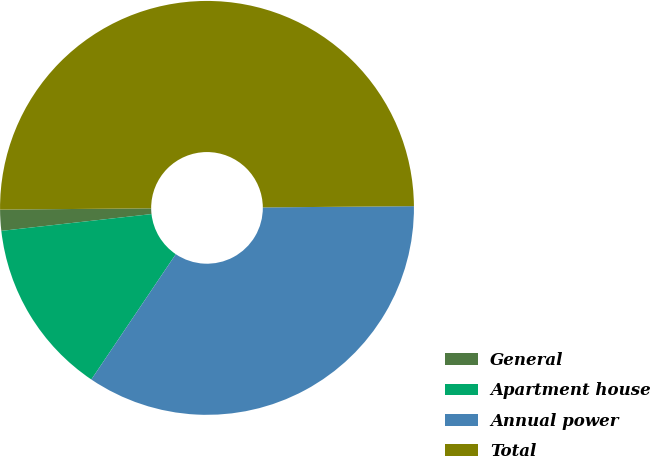Convert chart to OTSL. <chart><loc_0><loc_0><loc_500><loc_500><pie_chart><fcel>General<fcel>Apartment house<fcel>Annual power<fcel>Total<nl><fcel>1.64%<fcel>13.79%<fcel>34.57%<fcel>50.0%<nl></chart> 